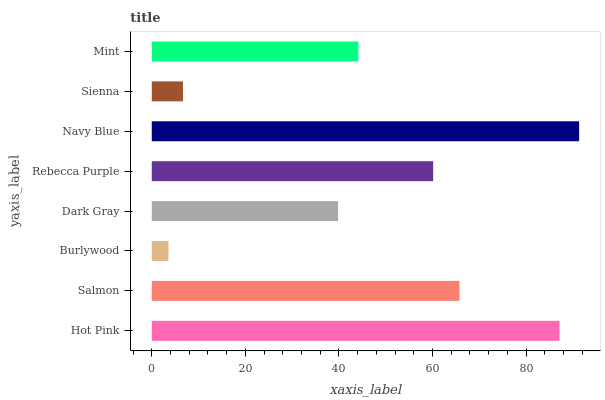Is Burlywood the minimum?
Answer yes or no. Yes. Is Navy Blue the maximum?
Answer yes or no. Yes. Is Salmon the minimum?
Answer yes or no. No. Is Salmon the maximum?
Answer yes or no. No. Is Hot Pink greater than Salmon?
Answer yes or no. Yes. Is Salmon less than Hot Pink?
Answer yes or no. Yes. Is Salmon greater than Hot Pink?
Answer yes or no. No. Is Hot Pink less than Salmon?
Answer yes or no. No. Is Rebecca Purple the high median?
Answer yes or no. Yes. Is Mint the low median?
Answer yes or no. Yes. Is Navy Blue the high median?
Answer yes or no. No. Is Burlywood the low median?
Answer yes or no. No. 